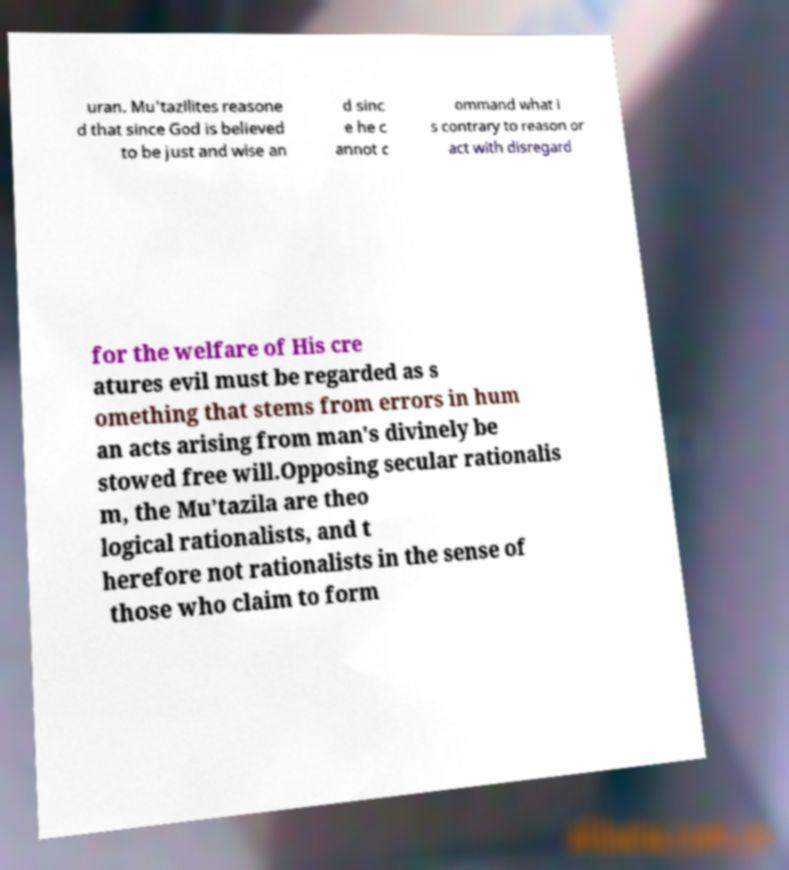Could you extract and type out the text from this image? uran. Mu'tazilites reasone d that since God is believed to be just and wise an d sinc e he c annot c ommand what i s contrary to reason or act with disregard for the welfare of His cre atures evil must be regarded as s omething that stems from errors in hum an acts arising from man's divinely be stowed free will.Opposing secular rationalis m, the Mu’tazila are theo logical rationalists, and t herefore not rationalists in the sense of those who claim to form 